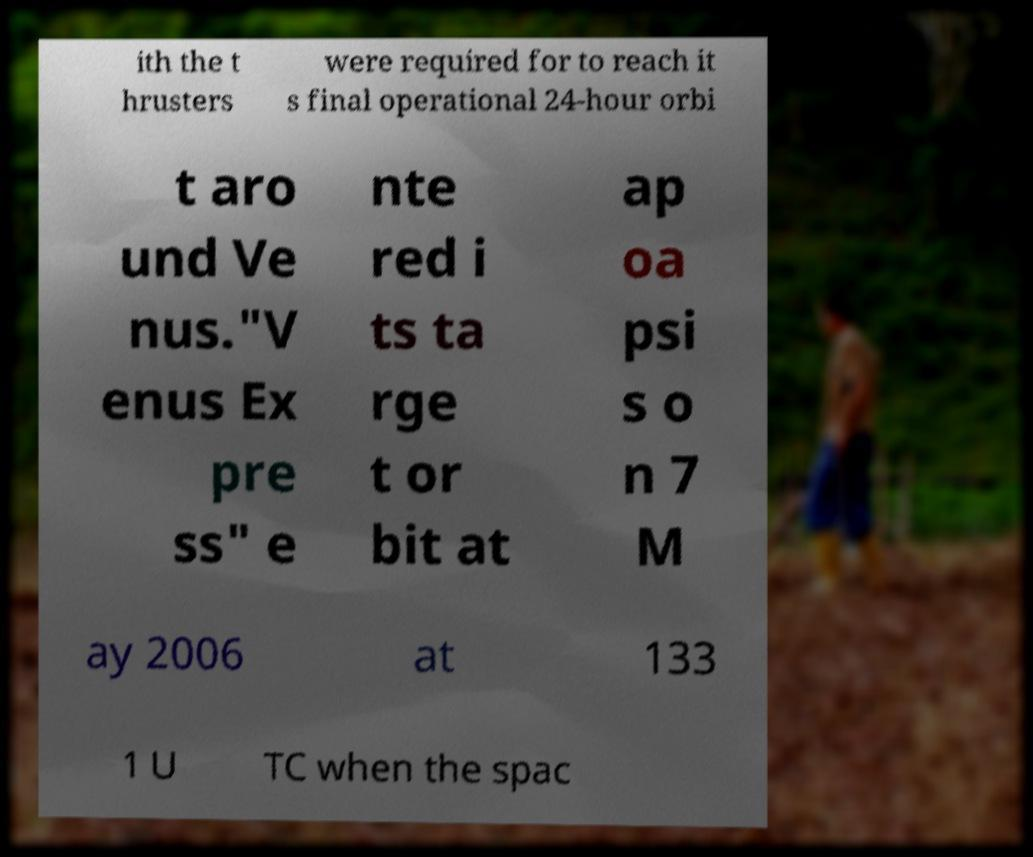Can you read and provide the text displayed in the image?This photo seems to have some interesting text. Can you extract and type it out for me? ith the t hrusters were required for to reach it s final operational 24-hour orbi t aro und Ve nus."V enus Ex pre ss" e nte red i ts ta rge t or bit at ap oa psi s o n 7 M ay 2006 at 133 1 U TC when the spac 